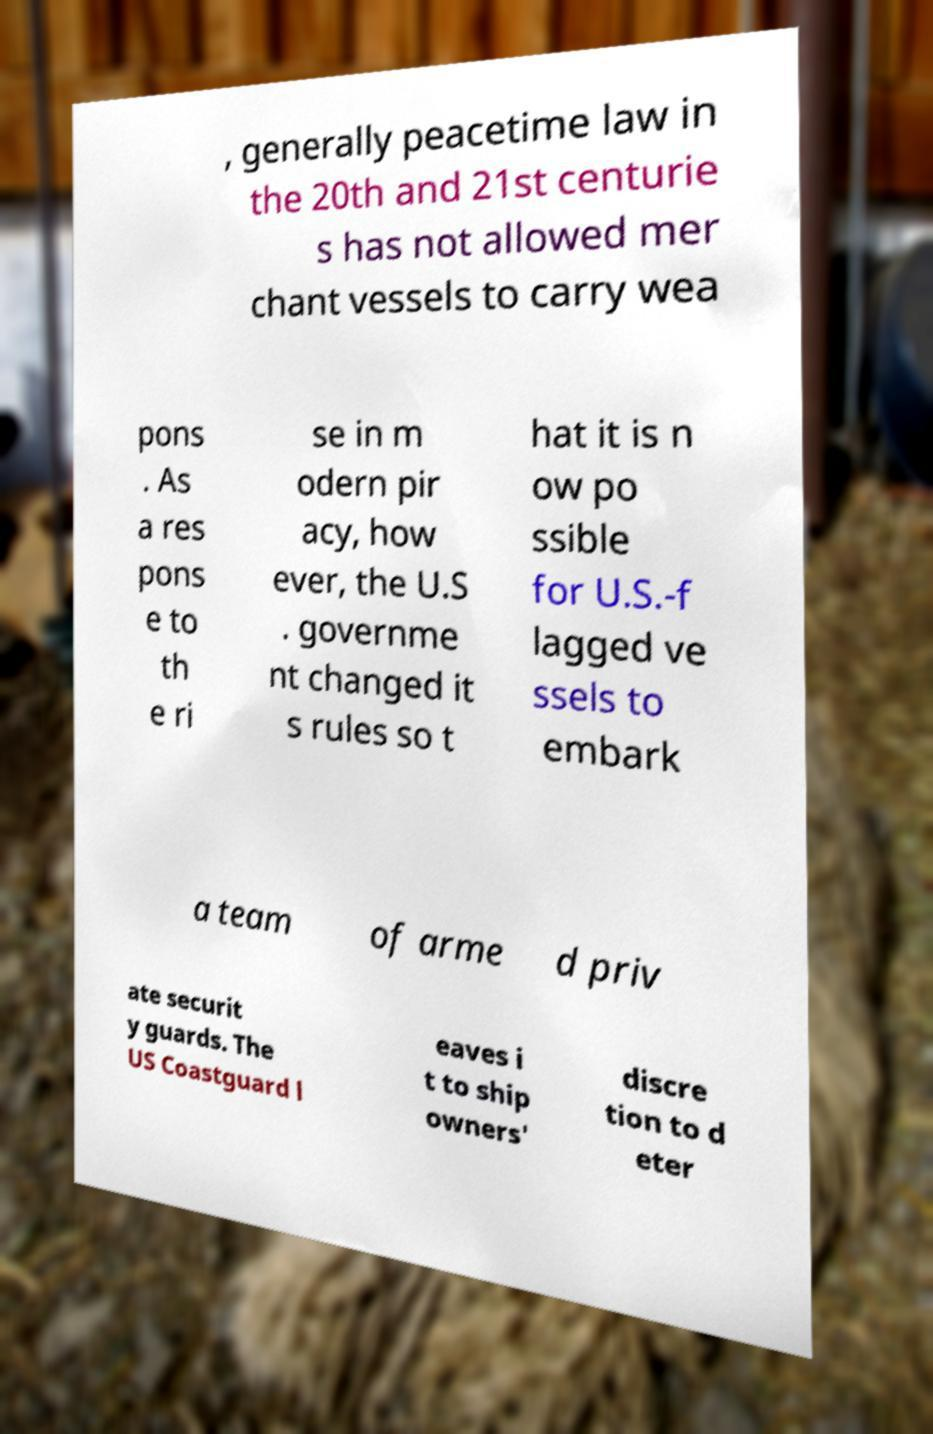For documentation purposes, I need the text within this image transcribed. Could you provide that? , generally peacetime law in the 20th and 21st centurie s has not allowed mer chant vessels to carry wea pons . As a res pons e to th e ri se in m odern pir acy, how ever, the U.S . governme nt changed it s rules so t hat it is n ow po ssible for U.S.-f lagged ve ssels to embark a team of arme d priv ate securit y guards. The US Coastguard l eaves i t to ship owners' discre tion to d eter 